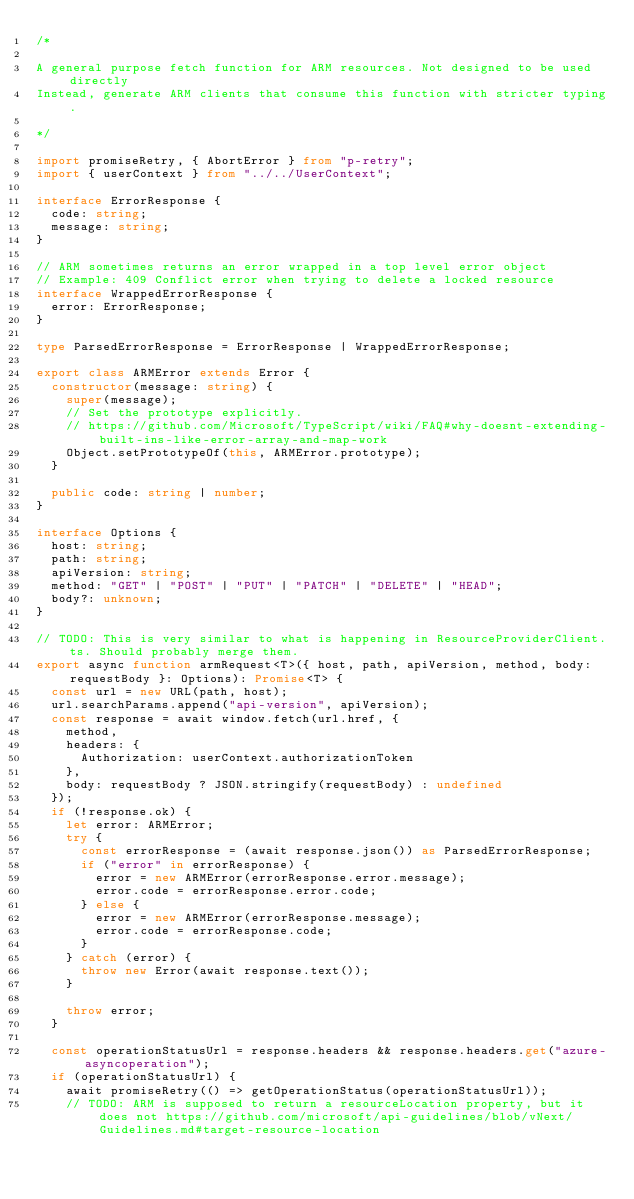<code> <loc_0><loc_0><loc_500><loc_500><_TypeScript_>/* 

A general purpose fetch function for ARM resources. Not designed to be used directly
Instead, generate ARM clients that consume this function with stricter typing.

*/

import promiseRetry, { AbortError } from "p-retry";
import { userContext } from "../../UserContext";

interface ErrorResponse {
  code: string;
  message: string;
}

// ARM sometimes returns an error wrapped in a top level error object
// Example: 409 Conflict error when trying to delete a locked resource
interface WrappedErrorResponse {
  error: ErrorResponse;
}

type ParsedErrorResponse = ErrorResponse | WrappedErrorResponse;

export class ARMError extends Error {
  constructor(message: string) {
    super(message);
    // Set the prototype explicitly.
    // https://github.com/Microsoft/TypeScript/wiki/FAQ#why-doesnt-extending-built-ins-like-error-array-and-map-work
    Object.setPrototypeOf(this, ARMError.prototype);
  }

  public code: string | number;
}

interface Options {
  host: string;
  path: string;
  apiVersion: string;
  method: "GET" | "POST" | "PUT" | "PATCH" | "DELETE" | "HEAD";
  body?: unknown;
}

// TODO: This is very similar to what is happening in ResourceProviderClient.ts. Should probably merge them.
export async function armRequest<T>({ host, path, apiVersion, method, body: requestBody }: Options): Promise<T> {
  const url = new URL(path, host);
  url.searchParams.append("api-version", apiVersion);
  const response = await window.fetch(url.href, {
    method,
    headers: {
      Authorization: userContext.authorizationToken
    },
    body: requestBody ? JSON.stringify(requestBody) : undefined
  });
  if (!response.ok) {
    let error: ARMError;
    try {
      const errorResponse = (await response.json()) as ParsedErrorResponse;
      if ("error" in errorResponse) {
        error = new ARMError(errorResponse.error.message);
        error.code = errorResponse.error.code;
      } else {
        error = new ARMError(errorResponse.message);
        error.code = errorResponse.code;
      }
    } catch (error) {
      throw new Error(await response.text());
    }

    throw error;
  }

  const operationStatusUrl = response.headers && response.headers.get("azure-asyncoperation");
  if (operationStatusUrl) {
    await promiseRetry(() => getOperationStatus(operationStatusUrl));
    // TODO: ARM is supposed to return a resourceLocation property, but it does not https://github.com/microsoft/api-guidelines/blob/vNext/Guidelines.md#target-resource-location</code> 